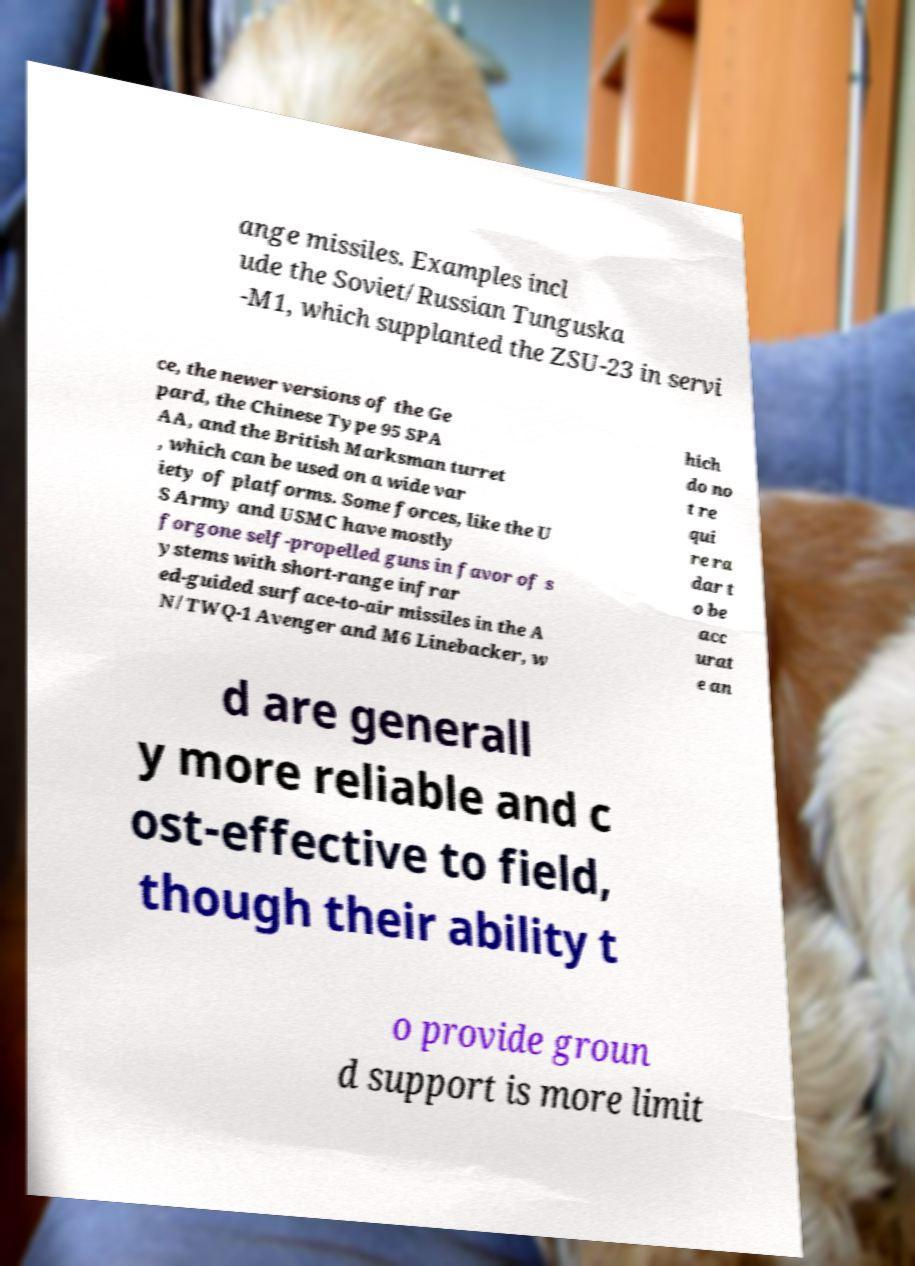There's text embedded in this image that I need extracted. Can you transcribe it verbatim? ange missiles. Examples incl ude the Soviet/Russian Tunguska -M1, which supplanted the ZSU-23 in servi ce, the newer versions of the Ge pard, the Chinese Type 95 SPA AA, and the British Marksman turret , which can be used on a wide var iety of platforms. Some forces, like the U S Army and USMC have mostly forgone self-propelled guns in favor of s ystems with short-range infrar ed-guided surface-to-air missiles in the A N/TWQ-1 Avenger and M6 Linebacker, w hich do no t re qui re ra dar t o be acc urat e an d are generall y more reliable and c ost-effective to field, though their ability t o provide groun d support is more limit 